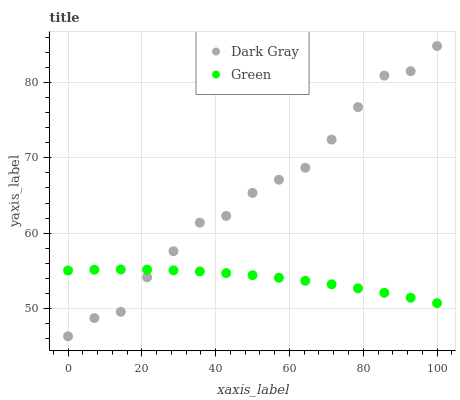Does Green have the minimum area under the curve?
Answer yes or no. Yes. Does Dark Gray have the maximum area under the curve?
Answer yes or no. Yes. Does Green have the maximum area under the curve?
Answer yes or no. No. Is Green the smoothest?
Answer yes or no. Yes. Is Dark Gray the roughest?
Answer yes or no. Yes. Is Green the roughest?
Answer yes or no. No. Does Dark Gray have the lowest value?
Answer yes or no. Yes. Does Green have the lowest value?
Answer yes or no. No. Does Dark Gray have the highest value?
Answer yes or no. Yes. Does Green have the highest value?
Answer yes or no. No. Does Green intersect Dark Gray?
Answer yes or no. Yes. Is Green less than Dark Gray?
Answer yes or no. No. Is Green greater than Dark Gray?
Answer yes or no. No. 